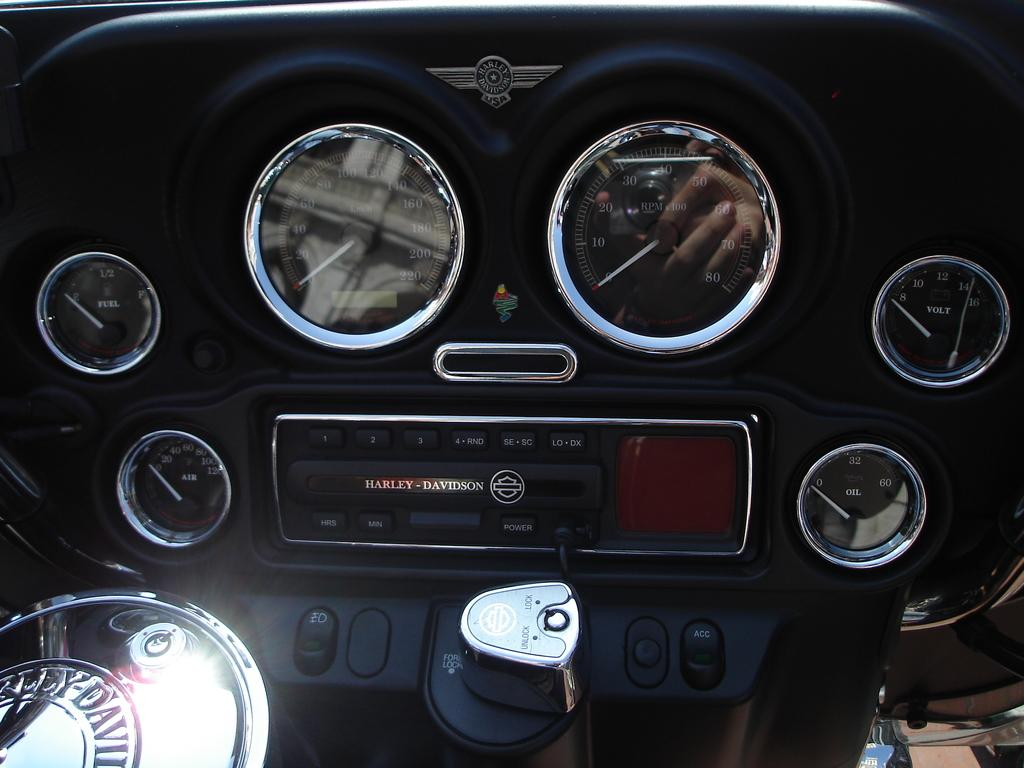What type of vehicle is in the image? There is a bike in the image. Which part of the bike is visible? The front part of the bike is visible. What instruments are present in the image? There is a speedometer, a fuel meter, an air meter, and an oil meter in the image. What type of controls can be seen in the image? There are buttons visible in the image. What is the purpose of the sign in the image? There is no sign present in the image. How does the bike contribute to harmony in the image? The image does not depict any concept of harmony, and the bike is the only subject present. 